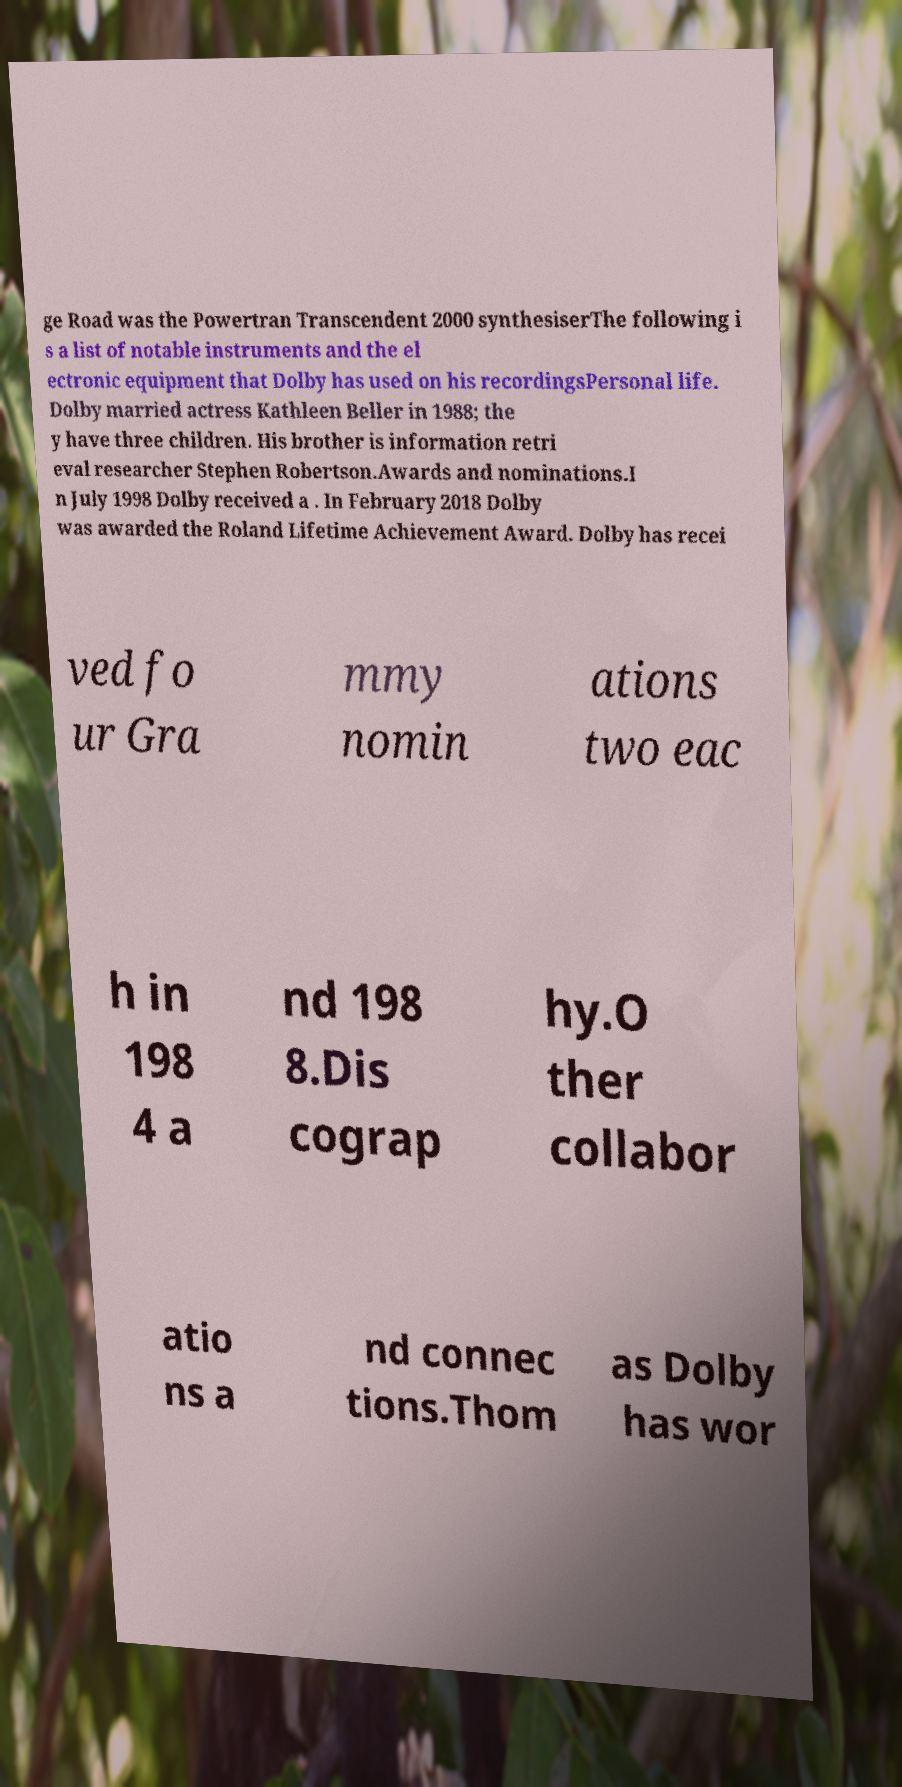Can you read and provide the text displayed in the image?This photo seems to have some interesting text. Can you extract and type it out for me? ge Road was the Powertran Transcendent 2000 synthesiserThe following i s a list of notable instruments and the el ectronic equipment that Dolby has used on his recordingsPersonal life. Dolby married actress Kathleen Beller in 1988; the y have three children. His brother is information retri eval researcher Stephen Robertson.Awards and nominations.I n July 1998 Dolby received a . In February 2018 Dolby was awarded the Roland Lifetime Achievement Award. Dolby has recei ved fo ur Gra mmy nomin ations two eac h in 198 4 a nd 198 8.Dis cograp hy.O ther collabor atio ns a nd connec tions.Thom as Dolby has wor 